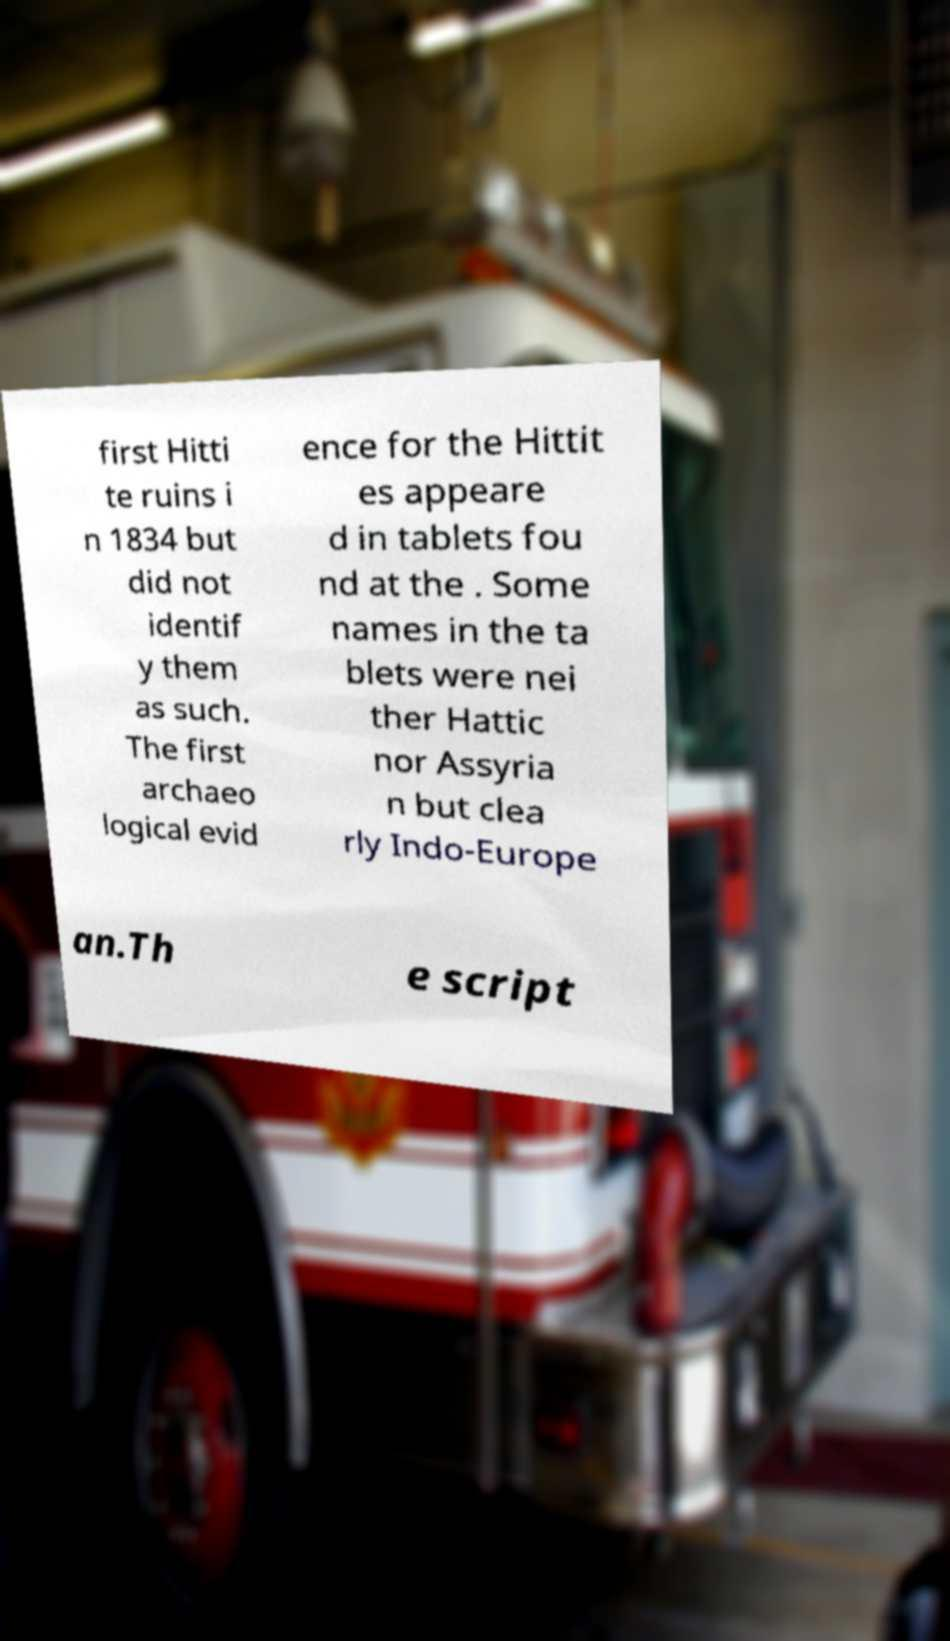What messages or text are displayed in this image? I need them in a readable, typed format. first Hitti te ruins i n 1834 but did not identif y them as such. The first archaeo logical evid ence for the Hittit es appeare d in tablets fou nd at the . Some names in the ta blets were nei ther Hattic nor Assyria n but clea rly Indo-Europe an.Th e script 